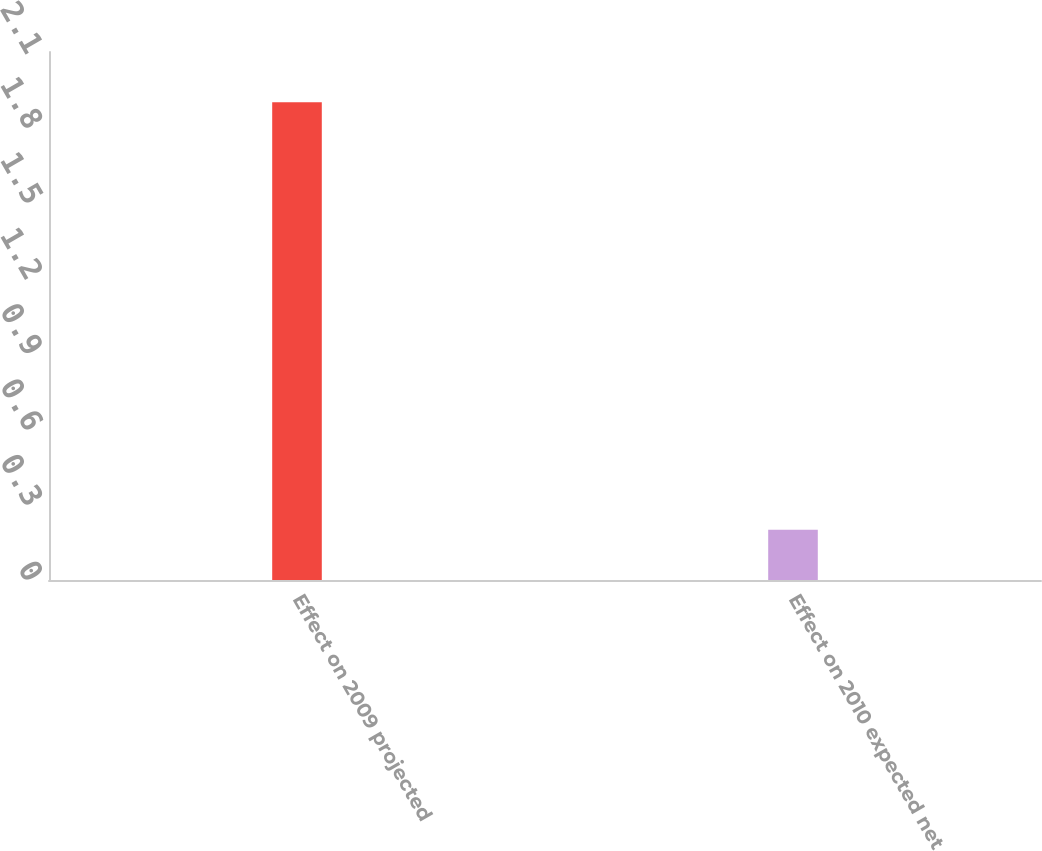<chart> <loc_0><loc_0><loc_500><loc_500><bar_chart><fcel>Effect on 2009 projected<fcel>Effect on 2010 expected net<nl><fcel>1.9<fcel>0.2<nl></chart> 